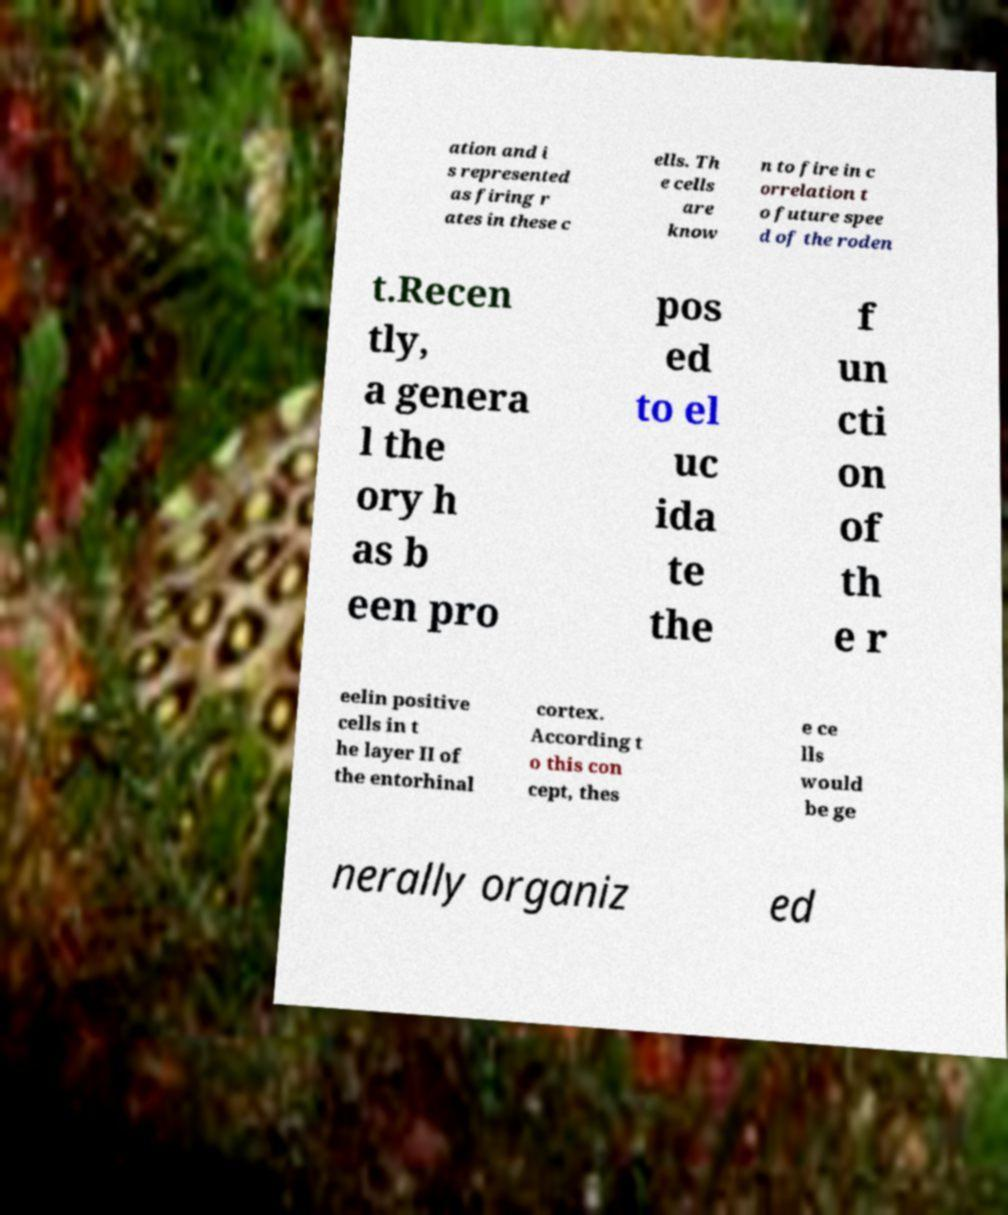Could you assist in decoding the text presented in this image and type it out clearly? ation and i s represented as firing r ates in these c ells. Th e cells are know n to fire in c orrelation t o future spee d of the roden t.Recen tly, a genera l the ory h as b een pro pos ed to el uc ida te the f un cti on of th e r eelin positive cells in t he layer II of the entorhinal cortex. According t o this con cept, thes e ce lls would be ge nerally organiz ed 